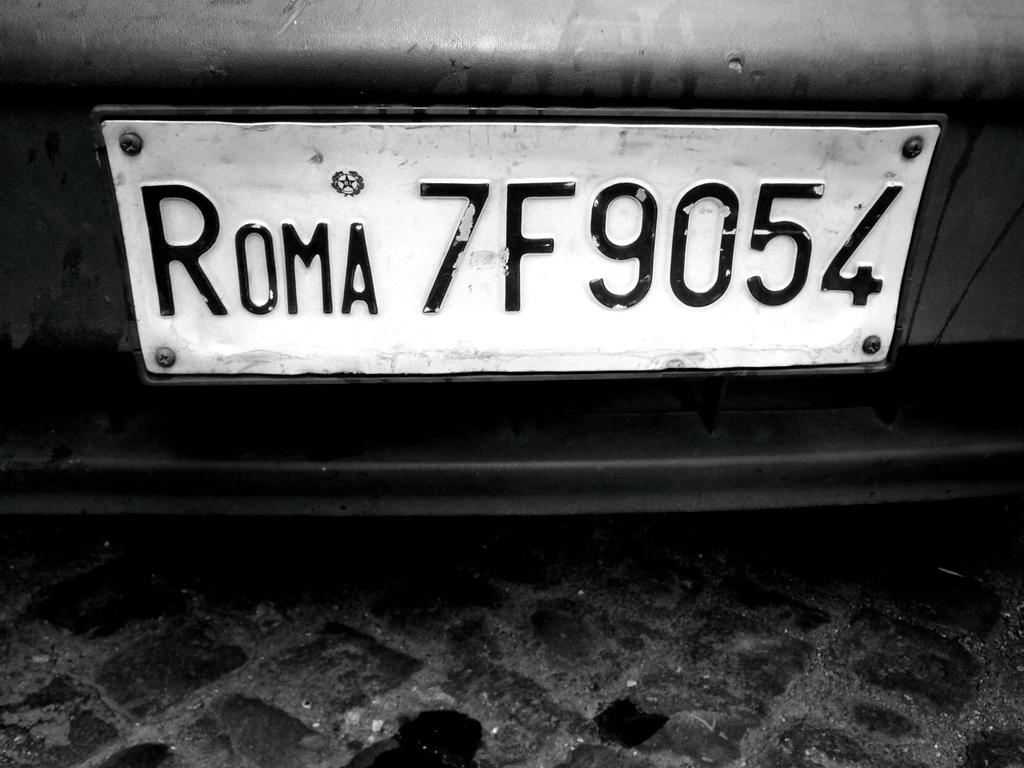<image>
Relay a brief, clear account of the picture shown. A black and white sign that reads Roma 7F9054. 